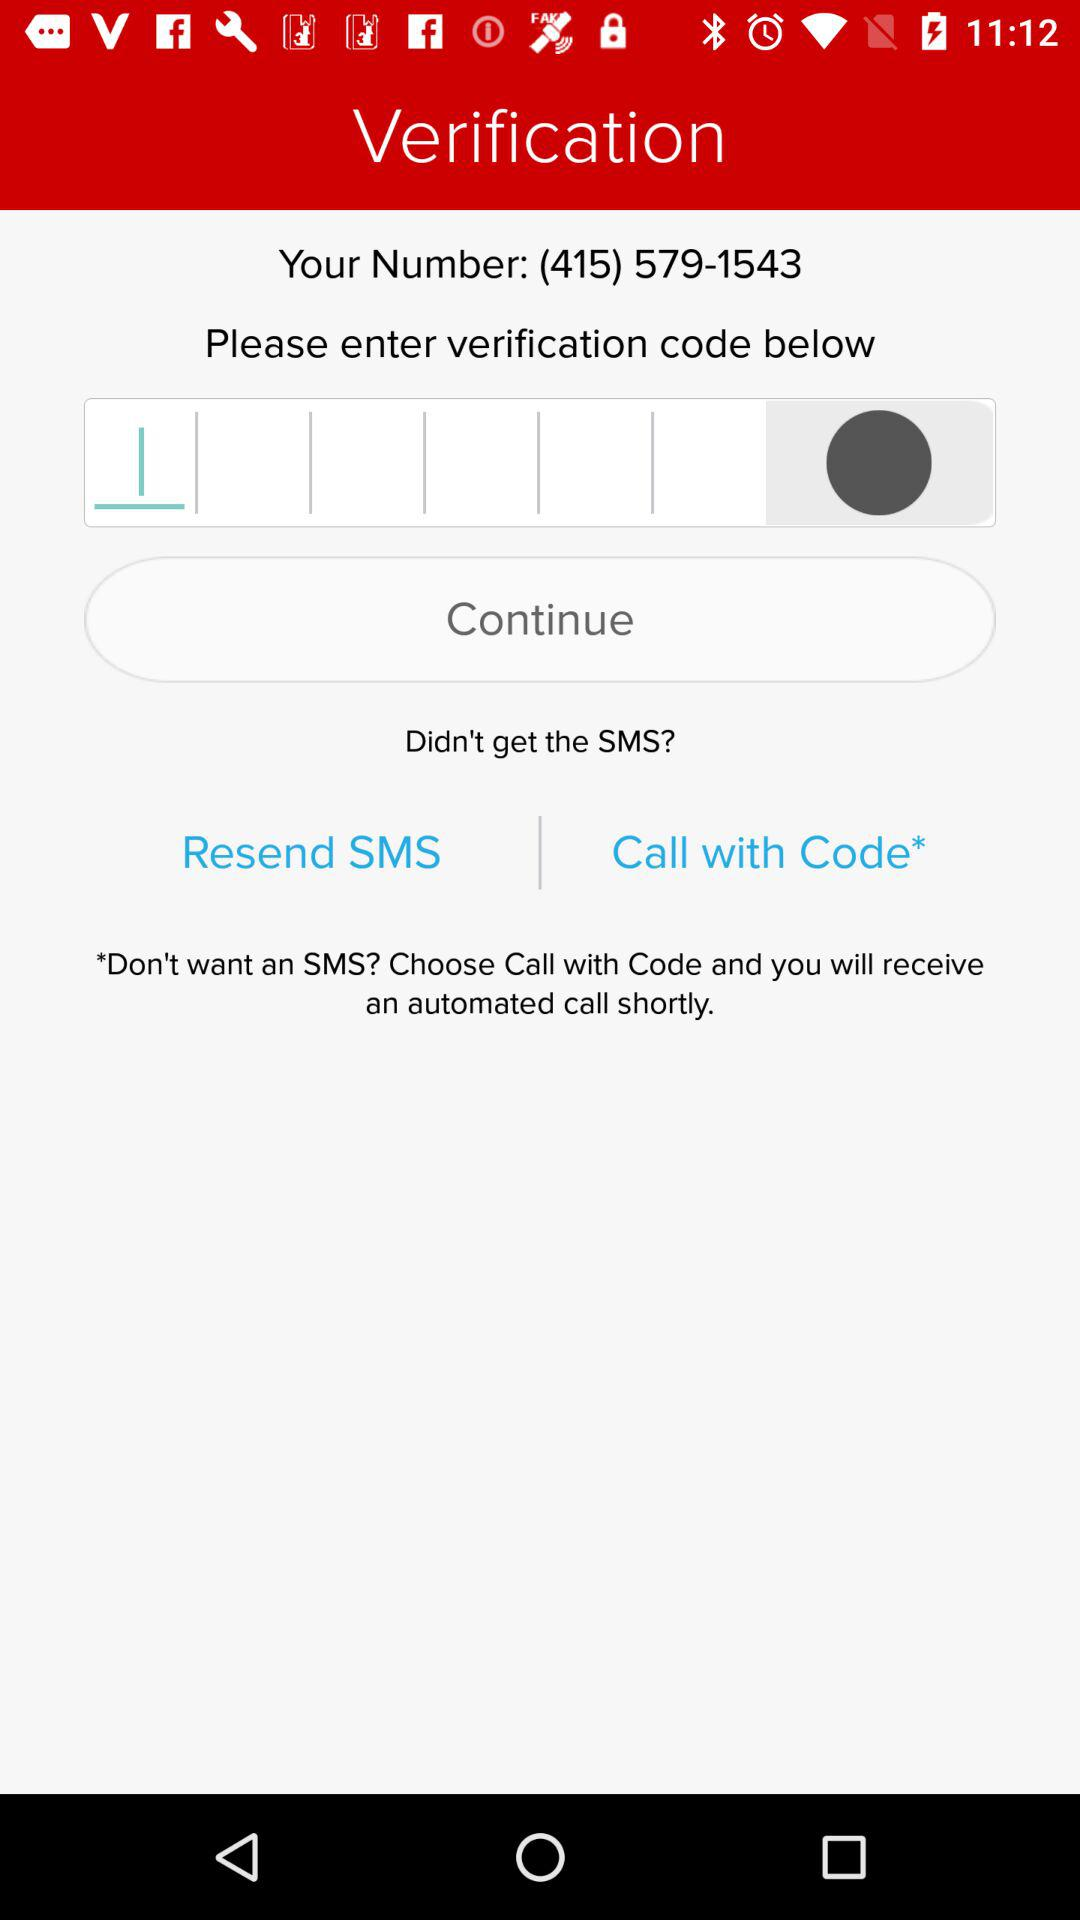What is the phone number? The phone number is (415) 579-1543. 